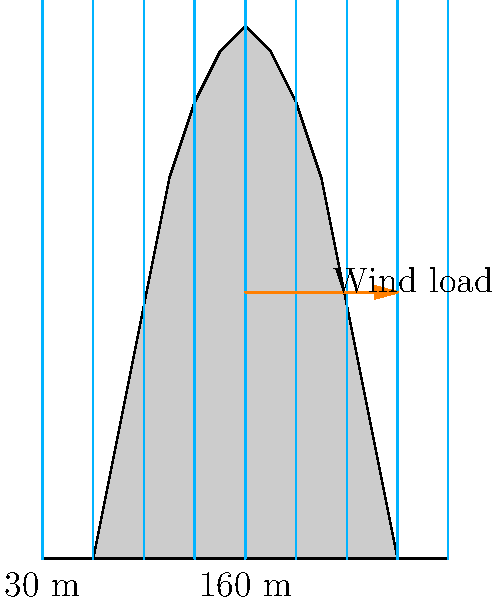As an eco-friendly clothing craftsman, you're designing a new workshop in a uniquely shaped tall building. The building has a height of 210 meters and a width of 160 meters at the base, with a curved profile as shown in the diagram. If the basic wind speed is 45 m/s and the terrain category is open country (Category 2), calculate the design wind pressure at the top of the building using the simplified method. Assume an importance factor of 1.0 and a topographic factor of 1.0. To calculate the design wind pressure, we'll follow these steps:

1. Calculate the velocity pressure exposure coefficient ($K_z$) at the top of the building:
   For open country (Category 2) and height $z = 210$ m,
   $K_z = 2.01 \left(\frac{z}{274.32}\right)^{2/9.5} = 2.01 \left(\frac{210}{274.32}\right)^{2/9.5} = 1.89$

2. Calculate the velocity pressure ($q_z$):
   $q_z = 0.613 K_z K_{zt} K_d V^2 I$ (in N/m²)
   Where:
   $K_z = 1.89$ (calculated above)
   $K_{zt} = 1.0$ (given topographic factor)
   $K_d = 0.85$ (wind directionality factor for buildings)
   $V = 45$ m/s (given basic wind speed)
   $I = 1.0$ (given importance factor)

   $q_z = 0.613 \times 1.89 \times 1.0 \times 0.85 \times 45^2 \times 1.0 = 1774.9$ N/m²

3. Calculate the design wind pressure ($p$):
   $p = q_z G C_p - q_i (GC_{pi})$
   Where:
   $q_z = 1774.9$ N/m² (calculated above)
   $G = 0.85$ (gust effect factor for rigid structures)
   $C_p = 0.8$ (external pressure coefficient for windward wall)
   $q_i = q_z$ (for simplicity, assume internal pressure equals external pressure)
   $GC_{pi} = ±0.18$ (internal pressure coefficient)

   $p = 1774.9 \times 0.85 \times 0.8 - 1774.9 \times (±0.18)$
   $p = 1208.9 ± 319.5$ N/m²

   The maximum design wind pressure occurs when the internal pressure acts in the same direction as the external pressure:
   $p_{max} = 1208.9 + 319.5 = 1528.4$ N/m²
Answer: 1528.4 N/m² 